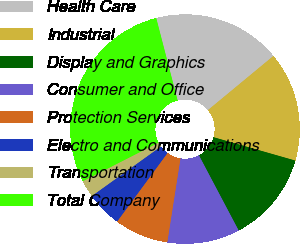<chart> <loc_0><loc_0><loc_500><loc_500><pie_chart><fcel>Health Care<fcel>Industrial<fcel>Display and Graphics<fcel>Consumer and Office<fcel>Protection Services<fcel>Electro and Communications<fcel>Transportation<fcel>Total Company<nl><fcel>18.04%<fcel>15.43%<fcel>12.83%<fcel>10.22%<fcel>7.61%<fcel>5.01%<fcel>2.4%<fcel>28.46%<nl></chart> 